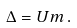<formula> <loc_0><loc_0><loc_500><loc_500>\Delta = U m \, .</formula> 